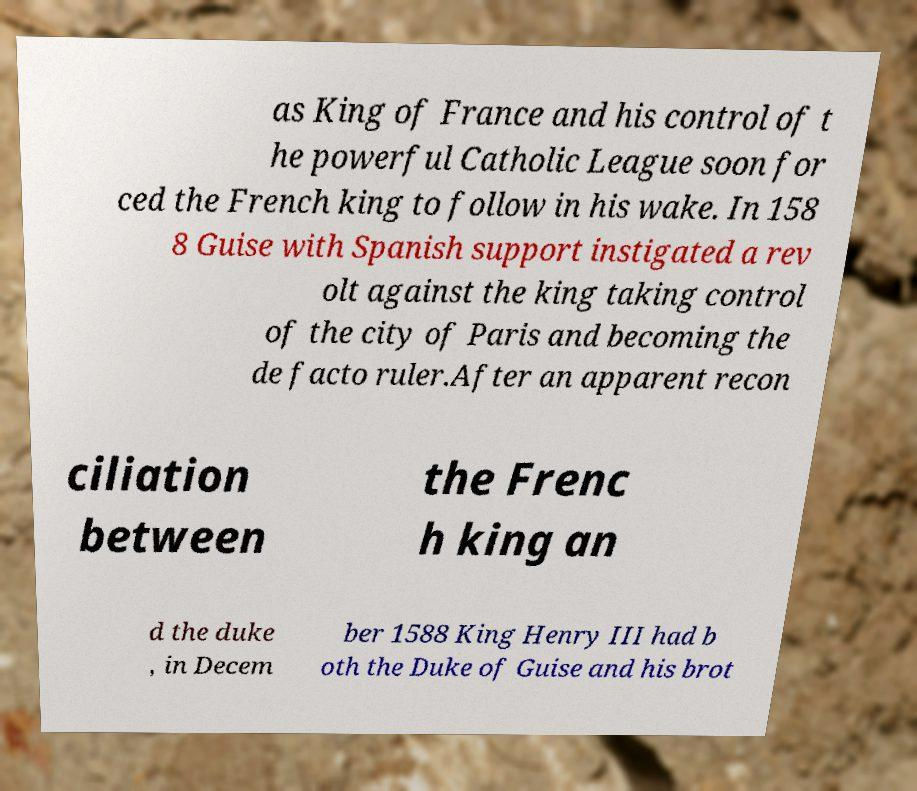Can you accurately transcribe the text from the provided image for me? as King of France and his control of t he powerful Catholic League soon for ced the French king to follow in his wake. In 158 8 Guise with Spanish support instigated a rev olt against the king taking control of the city of Paris and becoming the de facto ruler.After an apparent recon ciliation between the Frenc h king an d the duke , in Decem ber 1588 King Henry III had b oth the Duke of Guise and his brot 